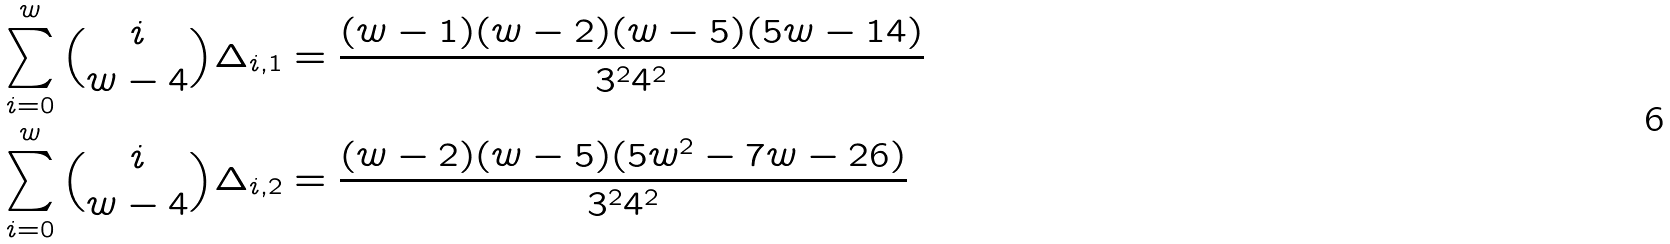Convert formula to latex. <formula><loc_0><loc_0><loc_500><loc_500>\sum _ { i = 0 } ^ { w } \binom { i } { w - 4 } \Delta _ { i , 1 } & = \frac { ( w - 1 ) ( w - 2 ) ( w - 5 ) ( 5 w - 1 4 ) } { 3 ^ { 2 } 4 ^ { 2 } } \\ \sum _ { i = 0 } ^ { w } \binom { i } { w - 4 } \Delta _ { i , 2 } & = \frac { ( w - 2 ) ( w - 5 ) ( 5 w ^ { 2 } - 7 w - 2 6 ) } { 3 ^ { 2 } 4 ^ { 2 } }</formula> 